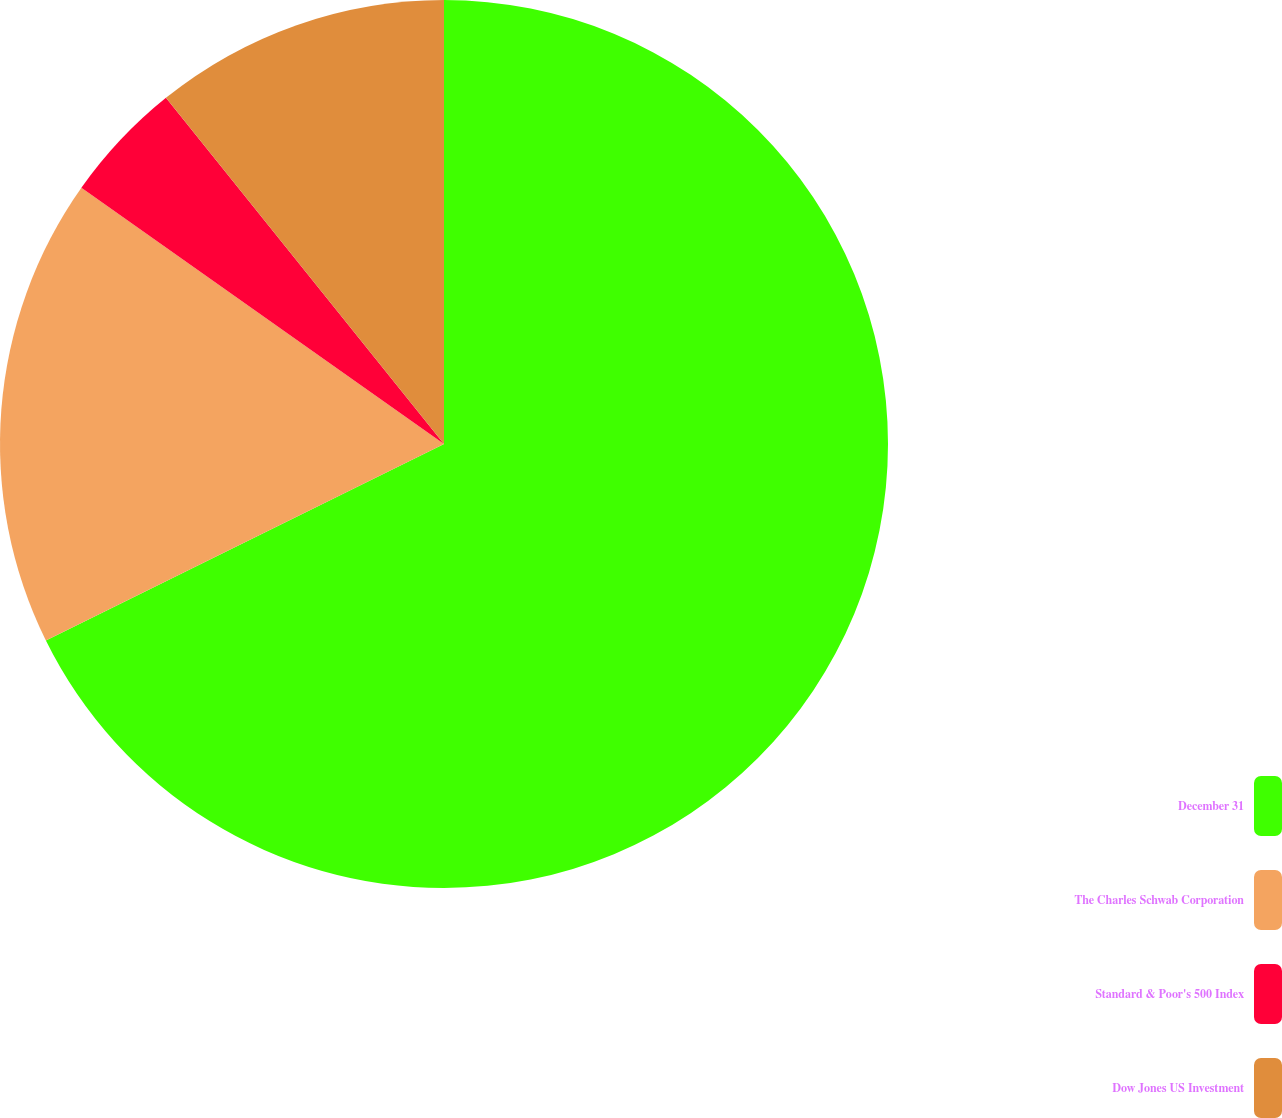Convert chart. <chart><loc_0><loc_0><loc_500><loc_500><pie_chart><fcel>December 31<fcel>The Charles Schwab Corporation<fcel>Standard & Poor's 500 Index<fcel>Dow Jones US Investment<nl><fcel>67.7%<fcel>17.09%<fcel>4.44%<fcel>10.77%<nl></chart> 